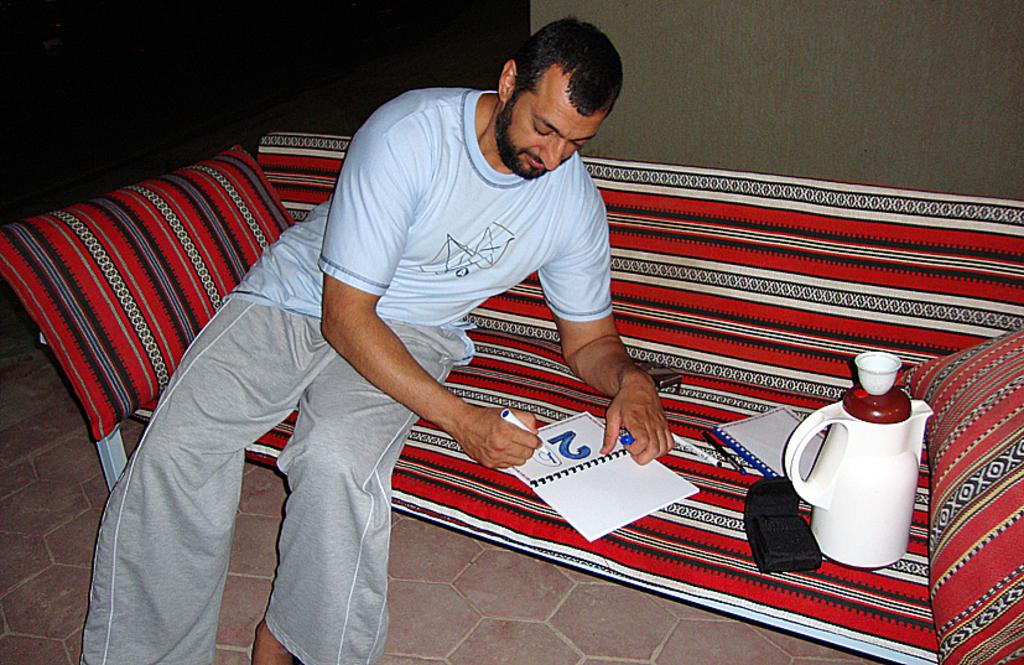<image>
Share a concise interpretation of the image provided. A man is sitting on a red, black, and white, striped couch, coloring in the number 20, with a blue marker, on a piece of paper. 